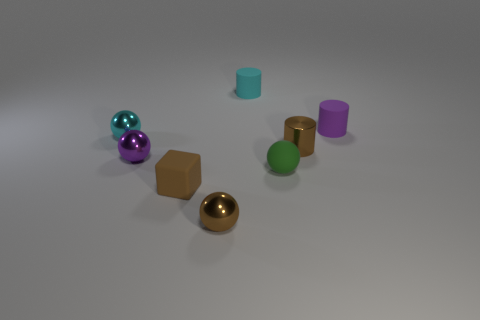Subtract all tiny matte cylinders. How many cylinders are left? 1 Subtract all brown cylinders. How many cylinders are left? 2 Subtract all cylinders. How many objects are left? 5 Subtract all purple cylinders. How many cyan balls are left? 1 Subtract all brown matte cylinders. Subtract all tiny rubber blocks. How many objects are left? 7 Add 6 tiny brown objects. How many tiny brown objects are left? 9 Add 1 rubber spheres. How many rubber spheres exist? 2 Add 1 purple rubber things. How many objects exist? 9 Subtract 0 gray blocks. How many objects are left? 8 Subtract 2 cylinders. How many cylinders are left? 1 